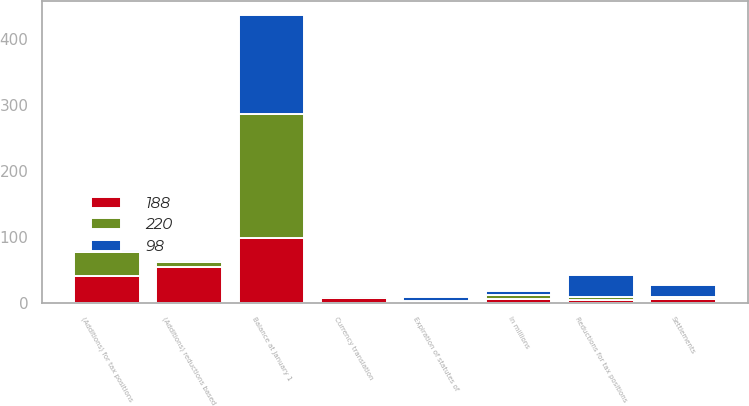<chart> <loc_0><loc_0><loc_500><loc_500><stacked_bar_chart><ecel><fcel>In millions<fcel>Balance at January 1<fcel>(Additions) reductions based<fcel>(Additions) for tax positions<fcel>Reductions for tax positions<fcel>Settlements<fcel>Expiration of statutes of<fcel>Currency translation<nl><fcel>220<fcel>6<fcel>188<fcel>7<fcel>37<fcel>5<fcel>2<fcel>2<fcel>3<nl><fcel>188<fcel>6<fcel>98<fcel>54<fcel>40<fcel>4<fcel>6<fcel>1<fcel>7<nl><fcel>98<fcel>6<fcel>150<fcel>4<fcel>3<fcel>33<fcel>19<fcel>5<fcel>2<nl></chart> 